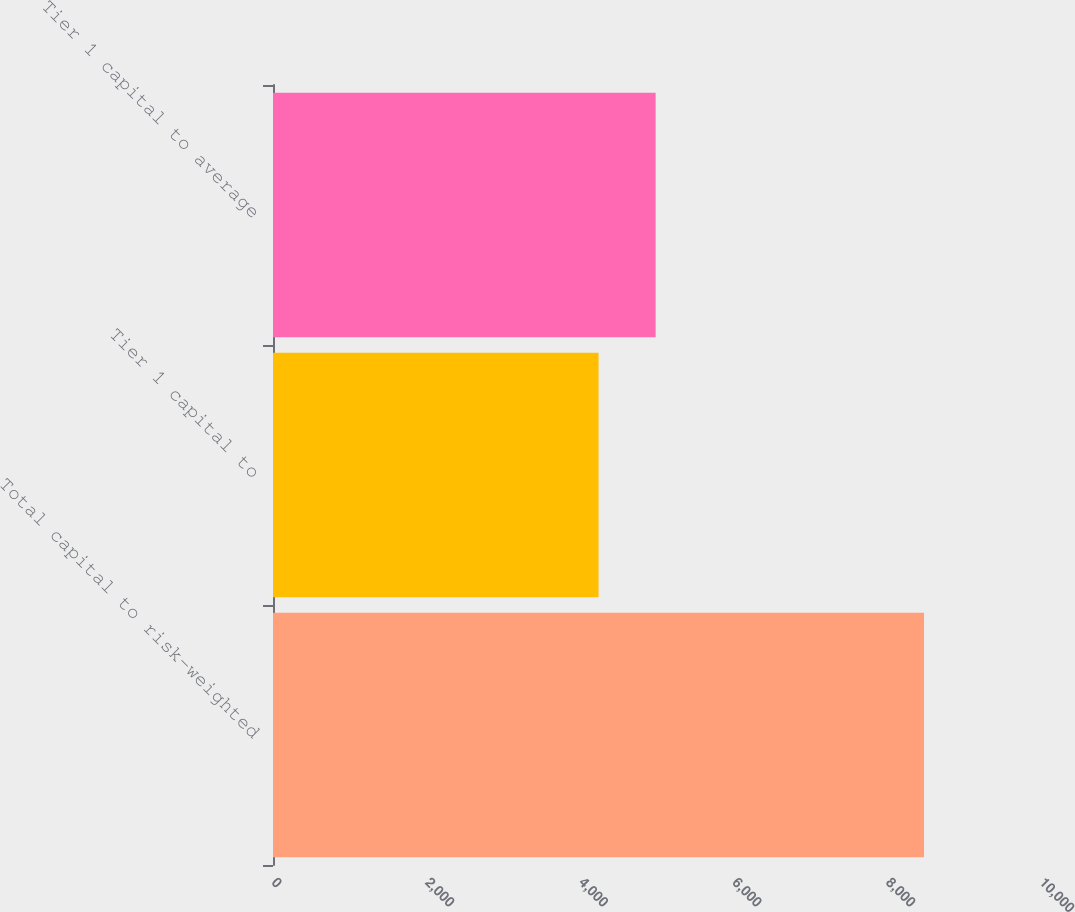Convert chart. <chart><loc_0><loc_0><loc_500><loc_500><bar_chart><fcel>Total capital to risk-weighted<fcel>Tier 1 capital to<fcel>Tier 1 capital to average<nl><fcel>8477<fcel>4239<fcel>4982<nl></chart> 